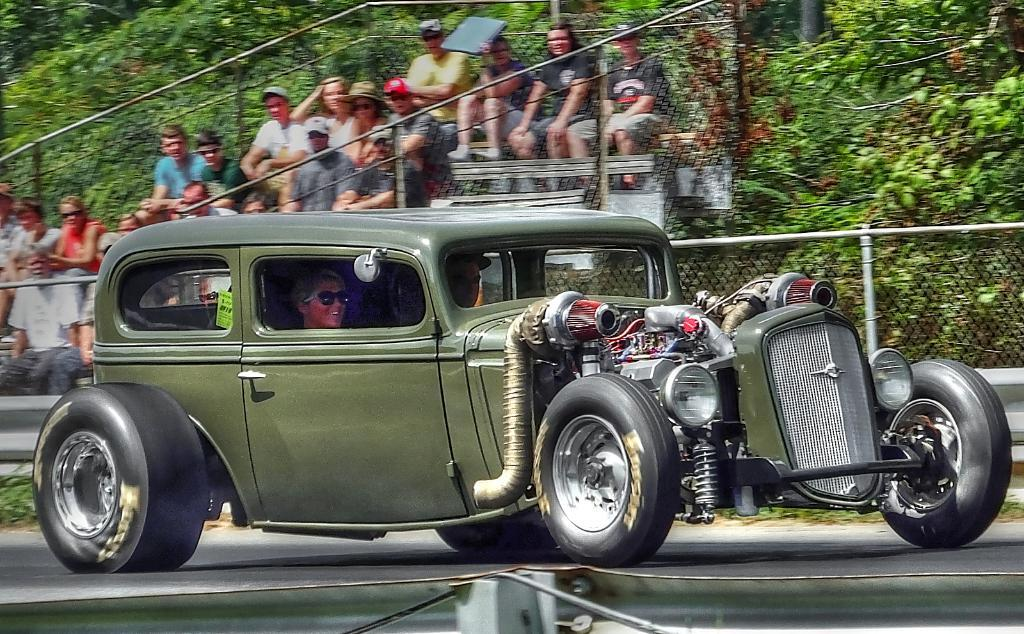What is the main subject of the image? The main subject of the image is a car. Where is the car located in the image? The car is on the road in the image. Are there any people visible in the image? Yes, there are people sitting on a staircase behind the car. What type of good-bye gesture can be seen between the car and the people on the staircase? There is no good-bye gesture visible between the car and the people on the staircase in the image. 